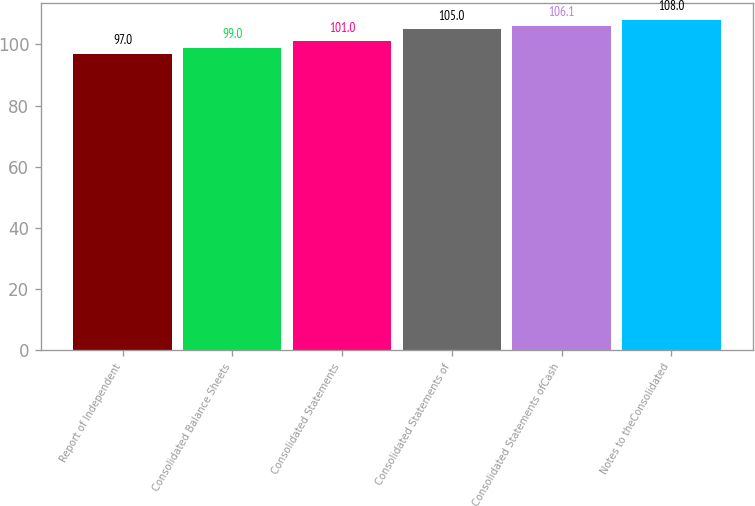Convert chart. <chart><loc_0><loc_0><loc_500><loc_500><bar_chart><fcel>Report of Independent<fcel>Consolidated Balance Sheets<fcel>Consolidated Statements<fcel>Consolidated Statements of<fcel>Consolidated Statements ofCash<fcel>Notes to theConsolidated<nl><fcel>97<fcel>99<fcel>101<fcel>105<fcel>106.1<fcel>108<nl></chart> 